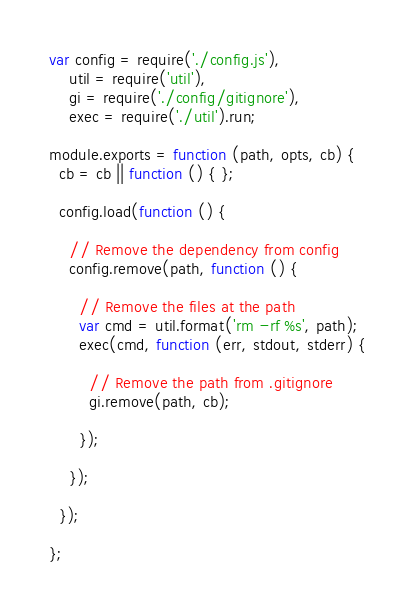<code> <loc_0><loc_0><loc_500><loc_500><_JavaScript_>var config = require('./config.js'),
    util = require('util'),
    gi = require('./config/gitignore'),
    exec = require('./util').run;

module.exports = function (path, opts, cb) {
  cb = cb || function () { };

  config.load(function () {

    // Remove the dependency from config
    config.remove(path, function () {

      // Remove the files at the path
      var cmd = util.format('rm -rf %s', path);
      exec(cmd, function (err, stdout, stderr) {

        // Remove the path from .gitignore
        gi.remove(path, cb);

      });

    });

  });

};
</code> 